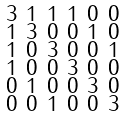<formula> <loc_0><loc_0><loc_500><loc_500>\begin{smallmatrix} 3 & 1 & 1 & 1 & 0 & 0 \\ 1 & 3 & 0 & 0 & 1 & 0 \\ 1 & 0 & 3 & 0 & 0 & 1 \\ 1 & 0 & 0 & 3 & 0 & 0 \\ 0 & 1 & 0 & 0 & 3 & 0 \\ 0 & 0 & 1 & 0 & 0 & 3 \end{smallmatrix}</formula> 